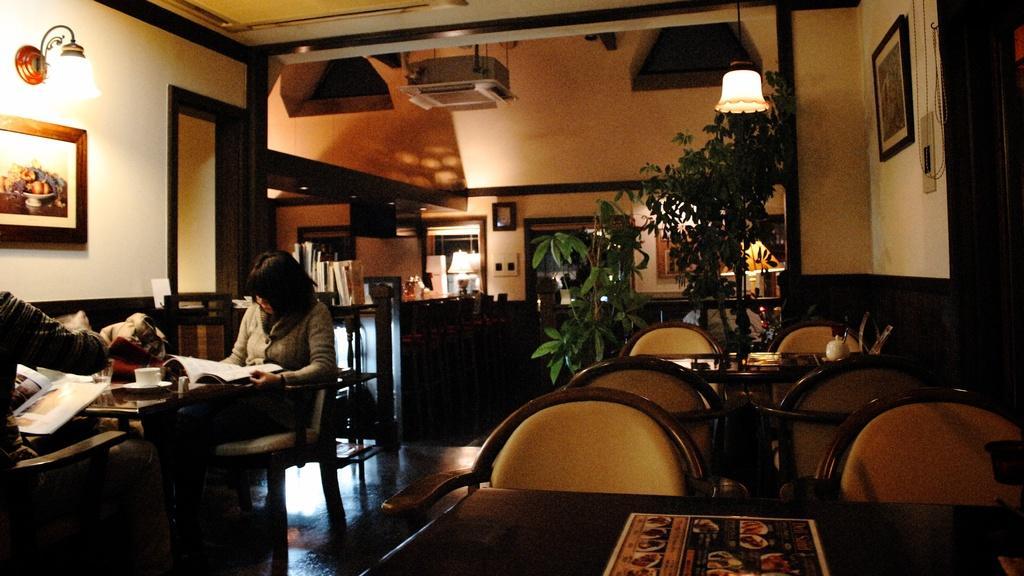Can you describe this image briefly? In a room there is a woman sitting and reading a book behind her there are so many tables and share and photo frames on the wall and some plants. 